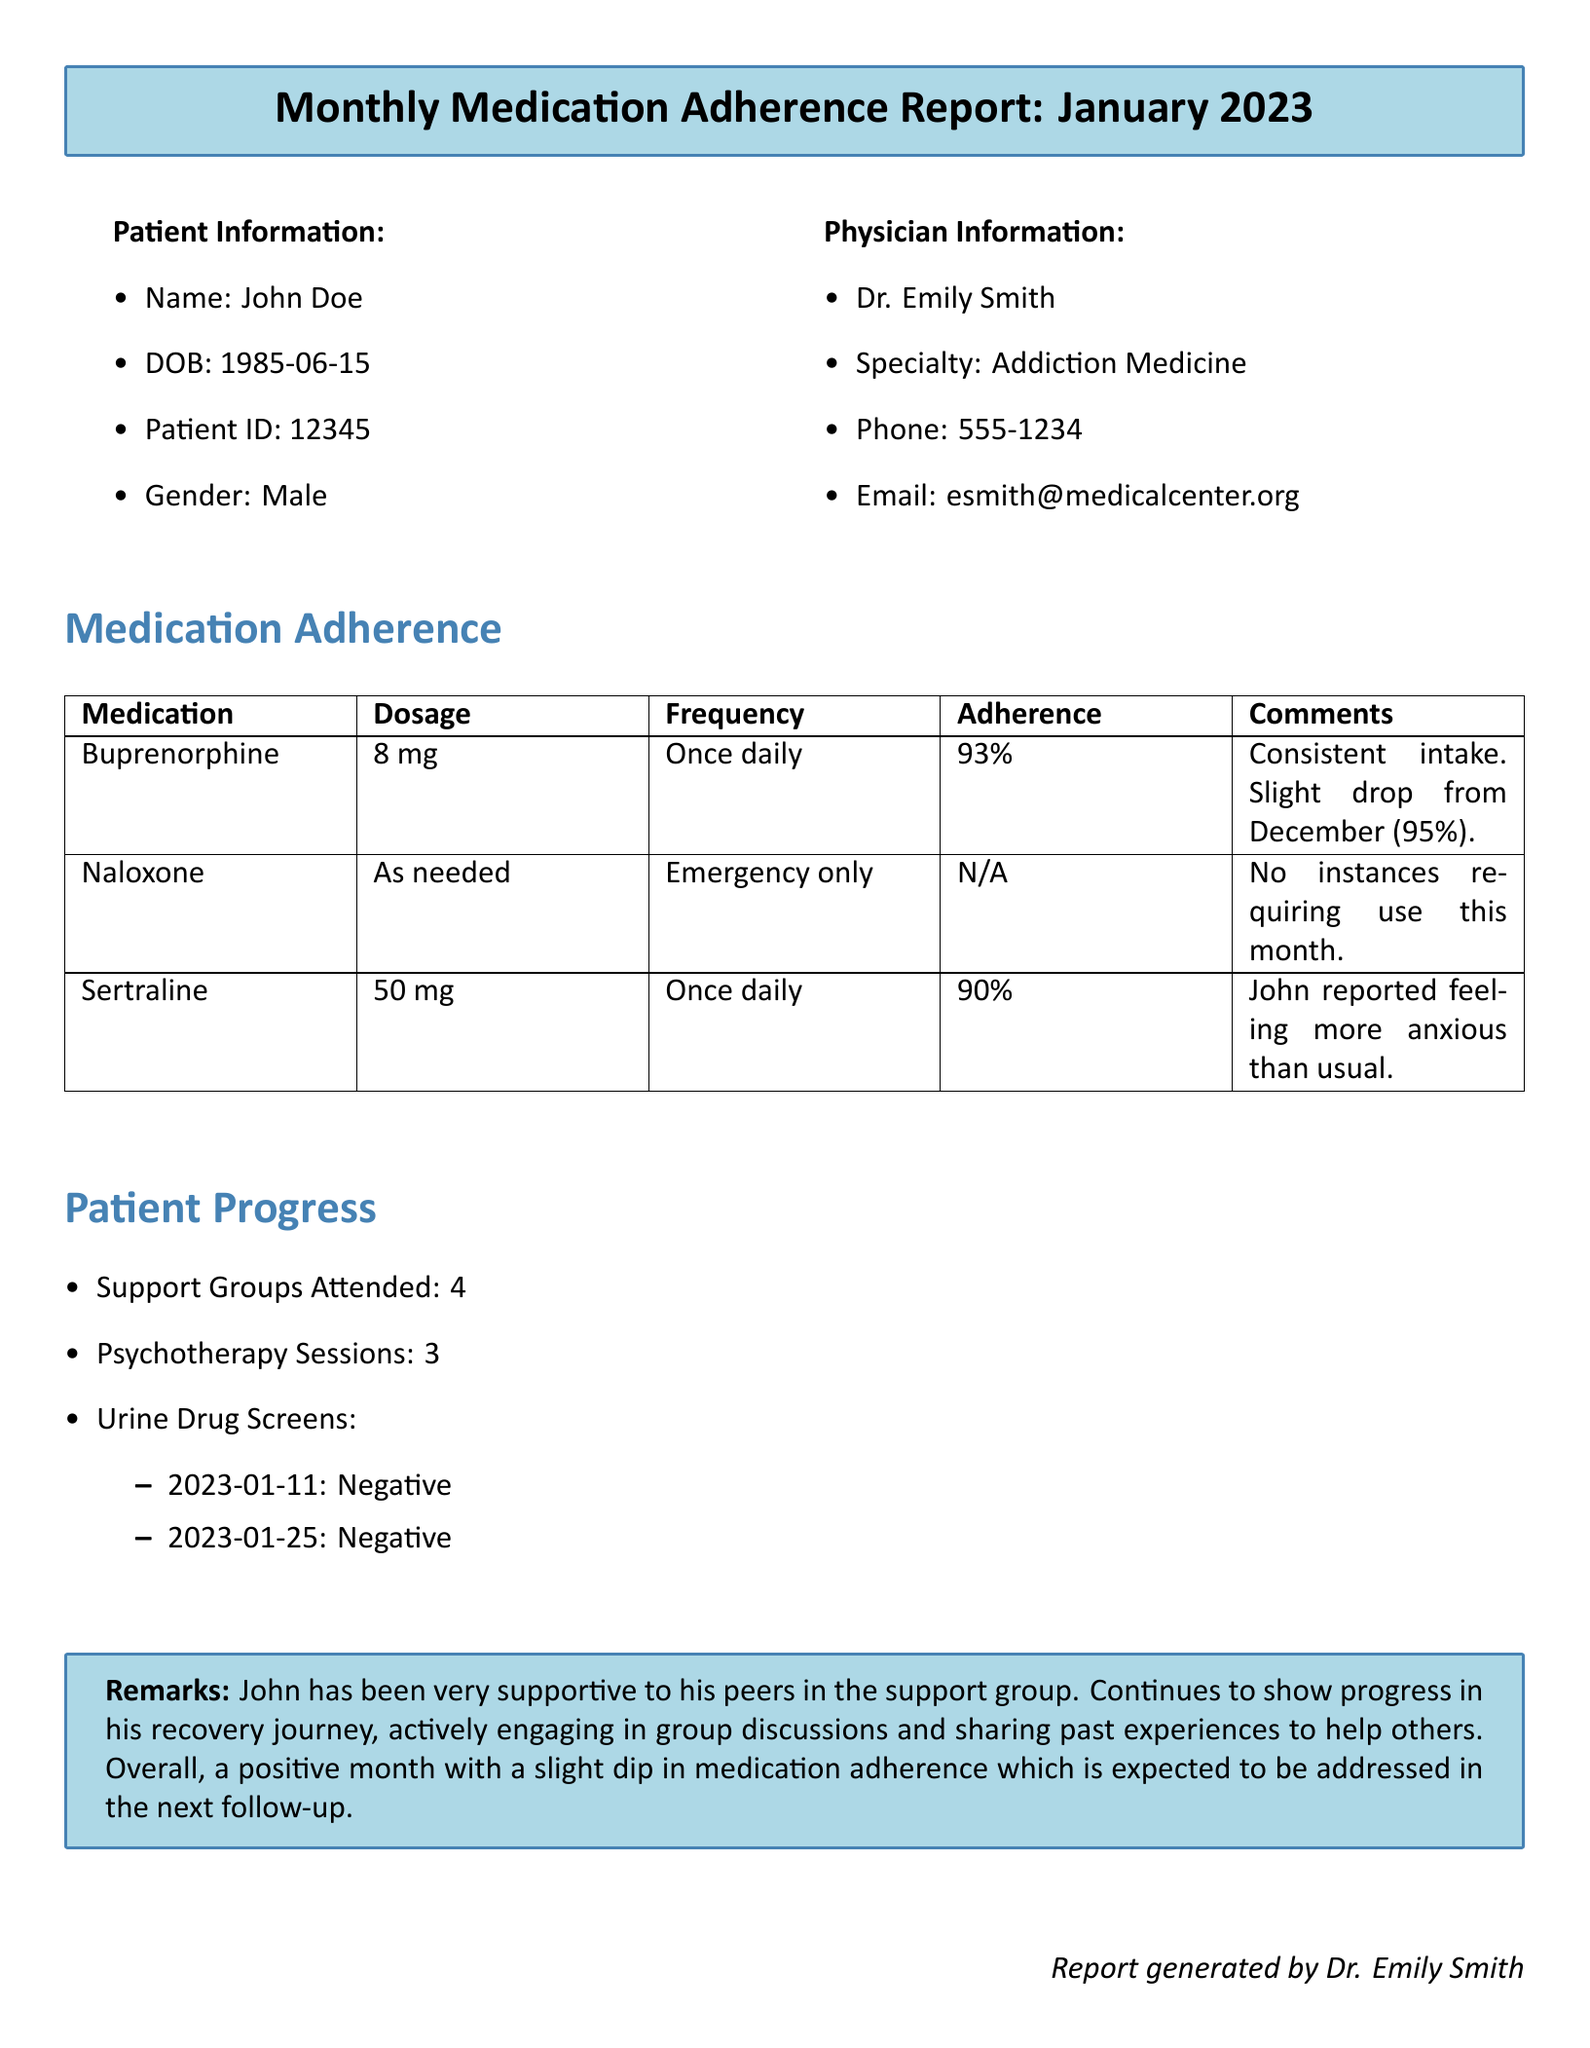What is the name of the patient? The document provides the patient's name under Patient Information, which is John Doe.
Answer: John Doe What is the physician's specialty? The specialty is listed under Physician Information, which indicates that Dr. Emily Smith practices Addiction Medicine.
Answer: Addiction Medicine What percentage adherence did John have for Buprenorphine? The adherence percentage for Buprenorphine is found in the Medication Adherence section, which states 93%.
Answer: 93% How many psychotherapy sessions did John attend? The number of psychotherapy sessions can be found in the Patient Progress section, showing that John attended 3 sessions.
Answer: 3 What was the last negative urine drug screen date? The last negative urine drug screen date is listed in the Urine Drug Screens section, indicating January 25, 2023.
Answer: 2023-01-25 What was the medication adherence percentage for Sertraline? The adherence percentage for Sertraline is noted in the Medication Adherence section, which states 90%.
Answer: 90% How many support groups did John attend? This information is specified under Patient Progress, detailing that John attended 4 support groups.
Answer: 4 What did John report feeling while on Sertraline? The comment under Sertraline in the Medication Adherence section states that John reported feeling more anxious than usual.
Answer: More anxious What is the email address of John's physician? The email address for Dr. Emily Smith is listed under Physician Information as esmith@medicalcenter.org.
Answer: esmith@medicalcenter.org 